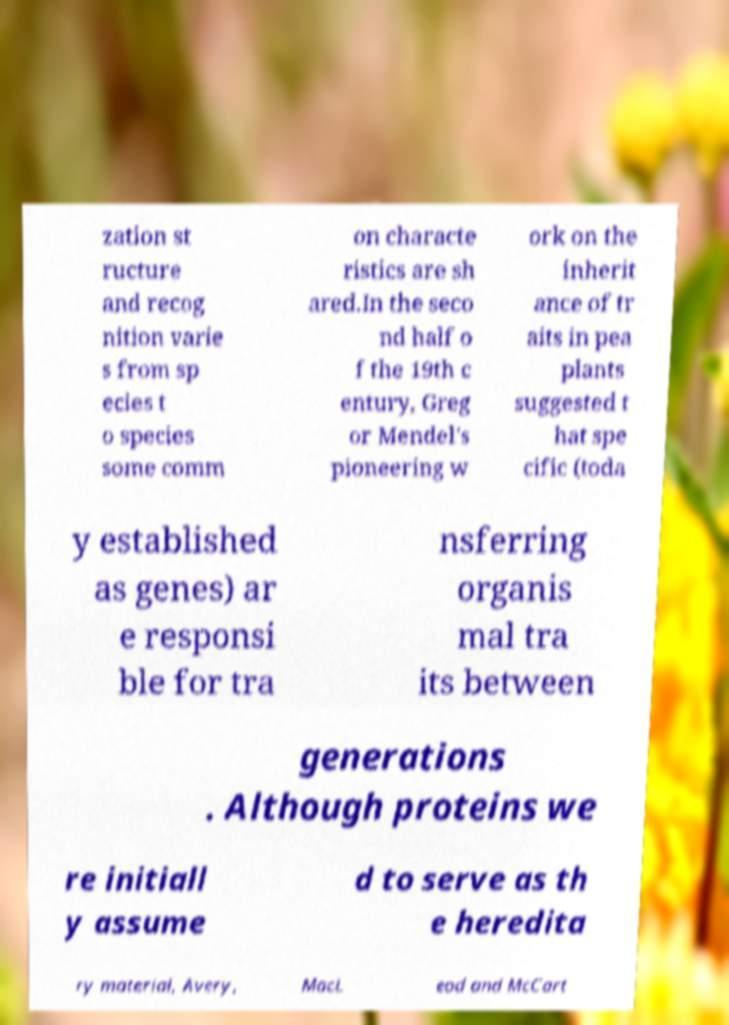Can you read and provide the text displayed in the image?This photo seems to have some interesting text. Can you extract and type it out for me? zation st ructure and recog nition varie s from sp ecies t o species some comm on characte ristics are sh ared.In the seco nd half o f the 19th c entury, Greg or Mendel's pioneering w ork on the inherit ance of tr aits in pea plants suggested t hat spe cific (toda y established as genes) ar e responsi ble for tra nsferring organis mal tra its between generations . Although proteins we re initiall y assume d to serve as th e heredita ry material, Avery, MacL eod and McCart 